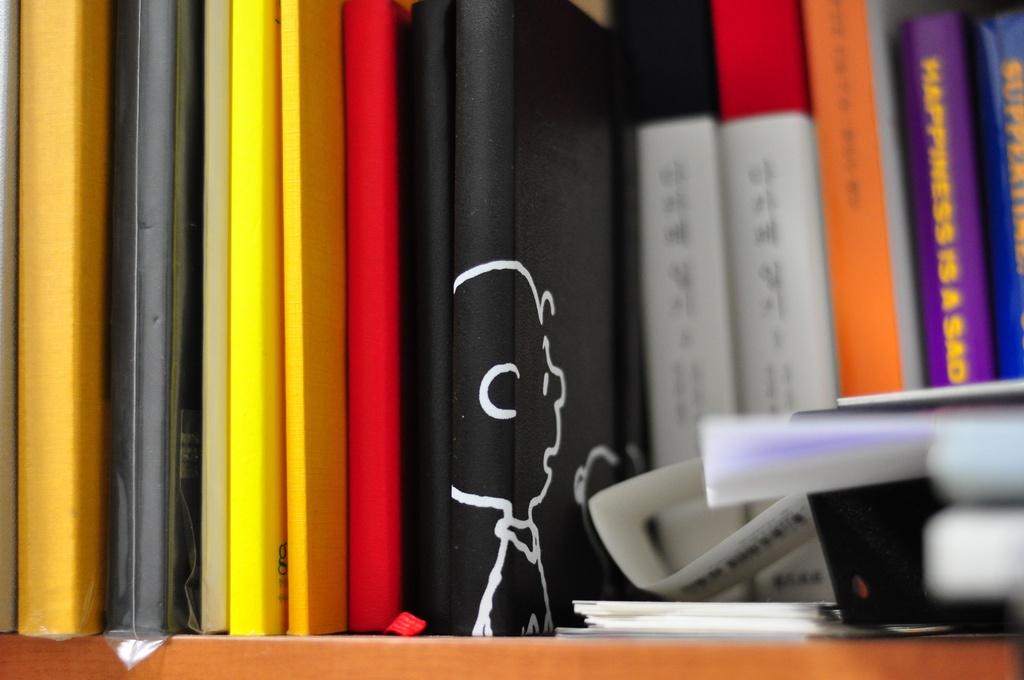What is the purple book about?
Ensure brevity in your answer.  Happiness. 